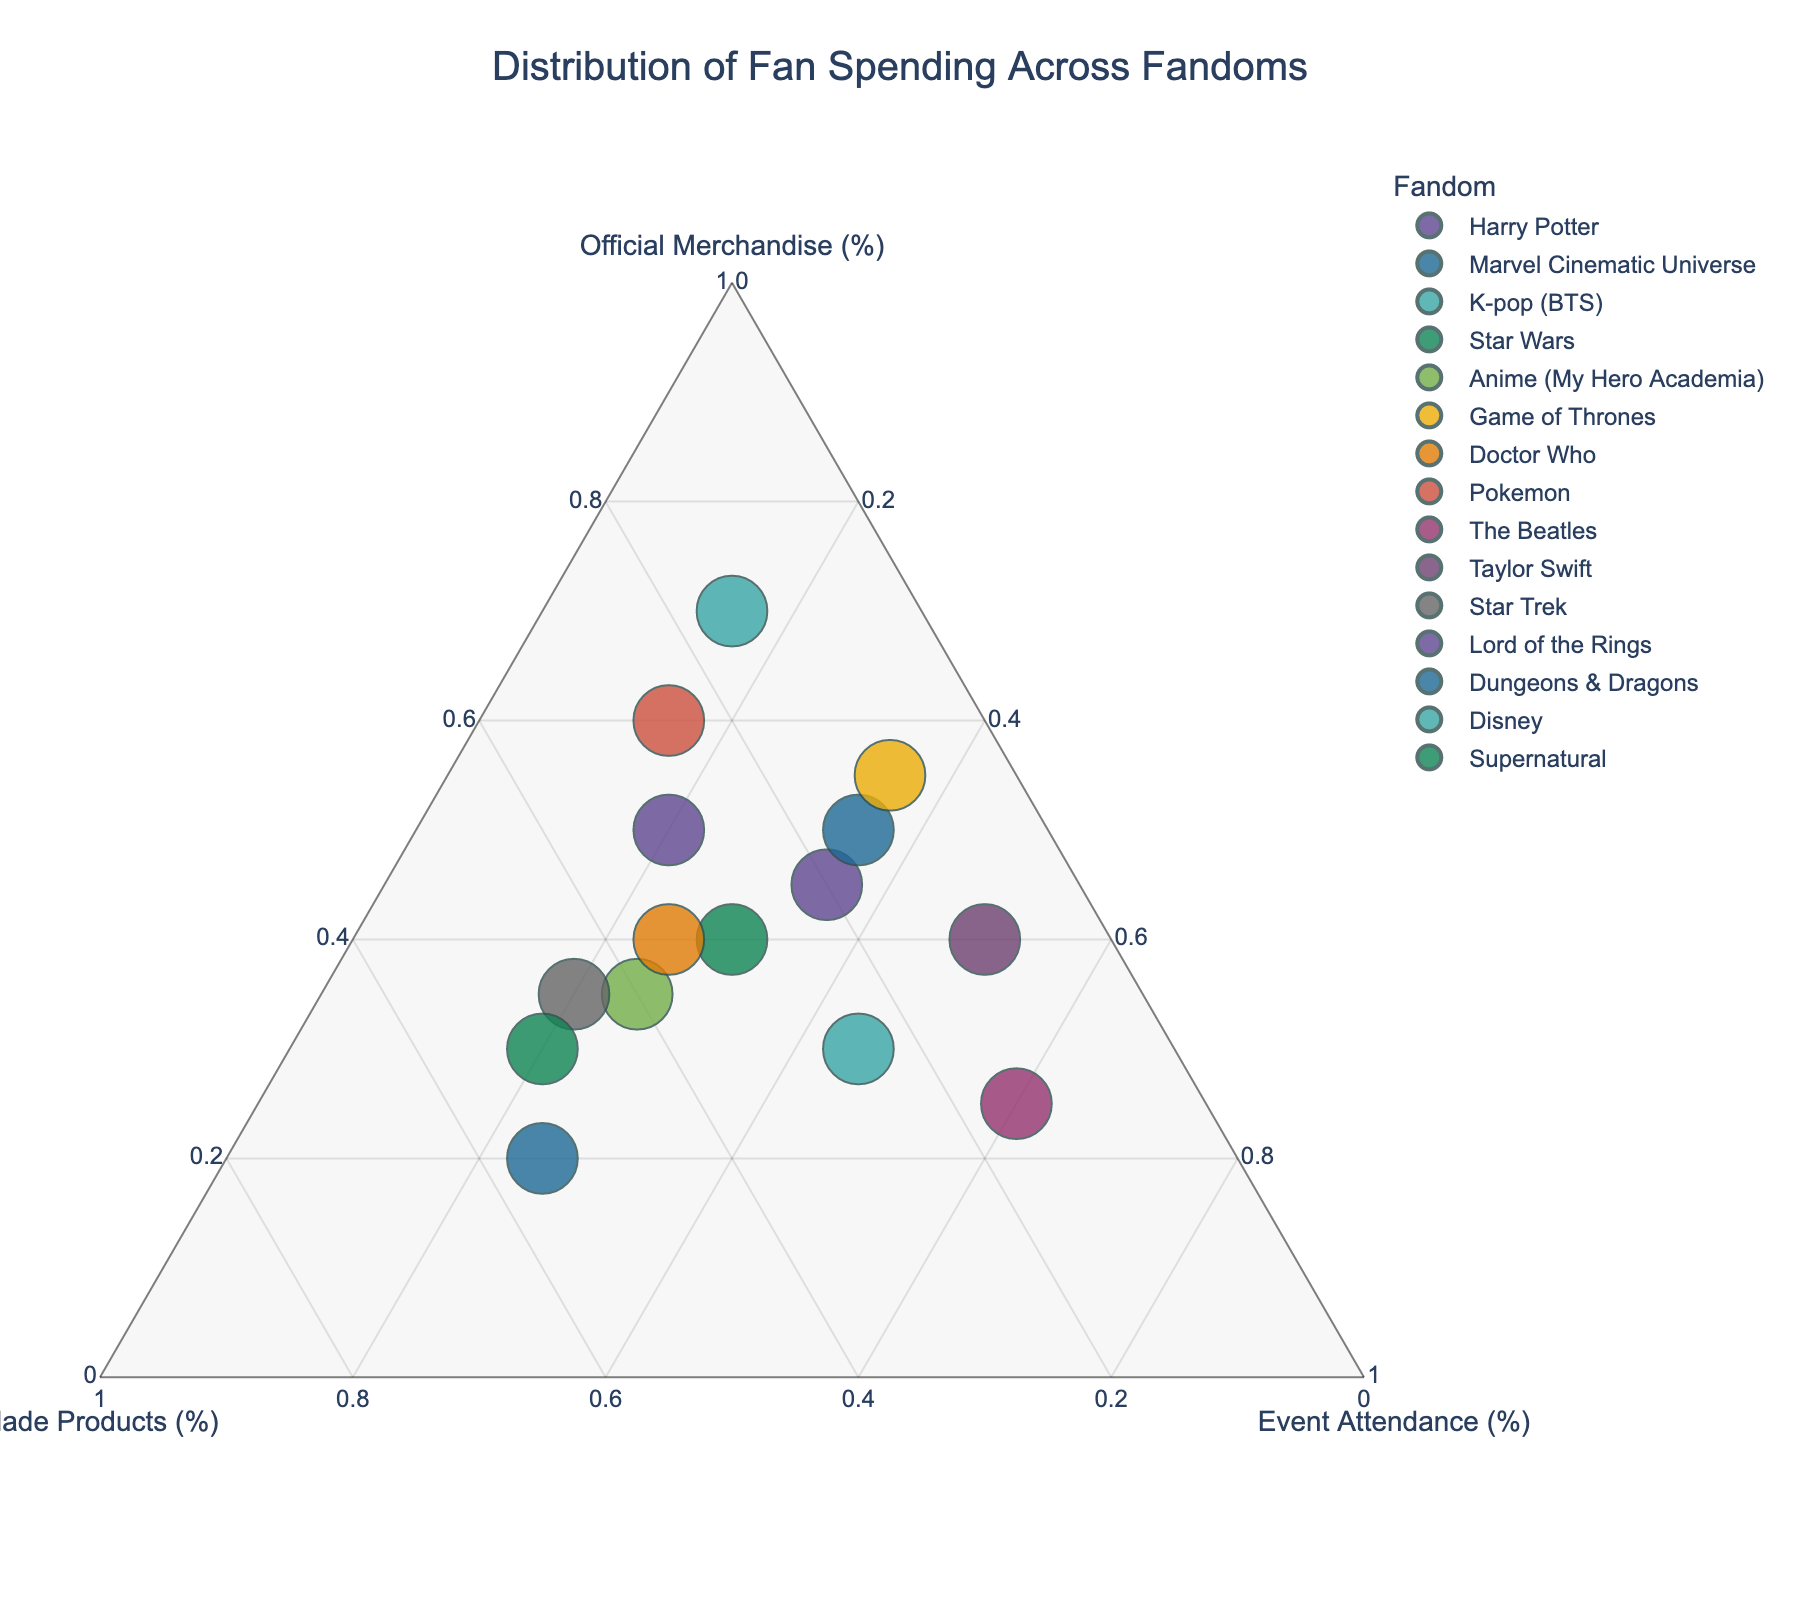Which fandom has the highest spending on official merchandise? Look for the data point with the highest percentage on the "Official Merchandise" axis.
Answer: Disney Which fandom spends the most on fan-made products? Identify the data point positioned the highest on the "Fan-Made Products" axis.
Answer: Dungeons & Dragons Between "Harry Potter" and "Star Wars," which fandom spends more on official merchandise? Compare the positions of these two fandoms on the "Official Merchandise" axis.
Answer: Harry Potter Which fandom has the smallest focus on event attendance? Find the data point closest to the "Event Attendance" axis origin.
Answer: Pokemon What percentage of spending is dedicated to event attendance for Taylor Swift fans? Note the position of "Taylor Swift" on the "Event Attendance" axis.
Answer: 50% Calculate the sum of percentages for fan-made products and event attendance for the Marvel Cinematic Universe. Add the percentage values of the Marvel Cinematic Universe for "Fan-Made Products" and "Event Attendance." 15% + 35% = 50%
Answer: 50% Compare the spending on official merchandise between K-pop (BTS) and The Beatles. Which is higher? Look at the positions of "K-pop (BTS)" and "The Beatles" on the "Official Merchandise" axis and compare them.
Answer: K-pop (BTS) Identify the fandom that has an equal percentage for official merchandise and event attendance. Find the data point where the values on the "Official Merchandise" and "Event Attendance" axes are the same.
Answer: Harry Potter Which fandom has the most balanced spending across all three categories? Look for the data point nearest to the center of the ternary plot.
Answer: Star Wars Rank the fandoms by the size of their total spending. Assess the sizes of the markers for each fandom, which represent their total spending, and rank accordingly.
Answer: Disney, Game of Thrones, Lord of the Rings, Marvel Cinematic Universe, Harry Potter, Taylor Swift, Star Wars, Doctor Who, Supernatural, K-pop (BTS), Anime (My Hero Academia), Star Trek, Pokemon, Dungeons & Dragons, The Beatles 